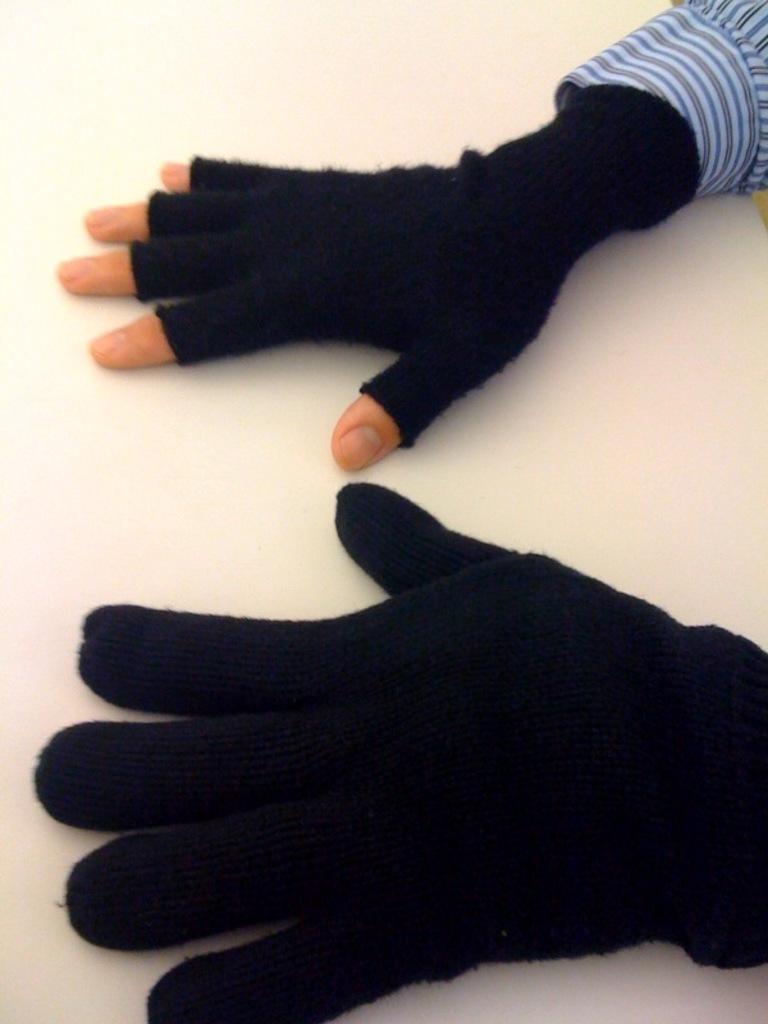Can you describe this image briefly? In this image there are two hands with glove. This is a half cut glove. In the top right we can see cuff of a shirt. 